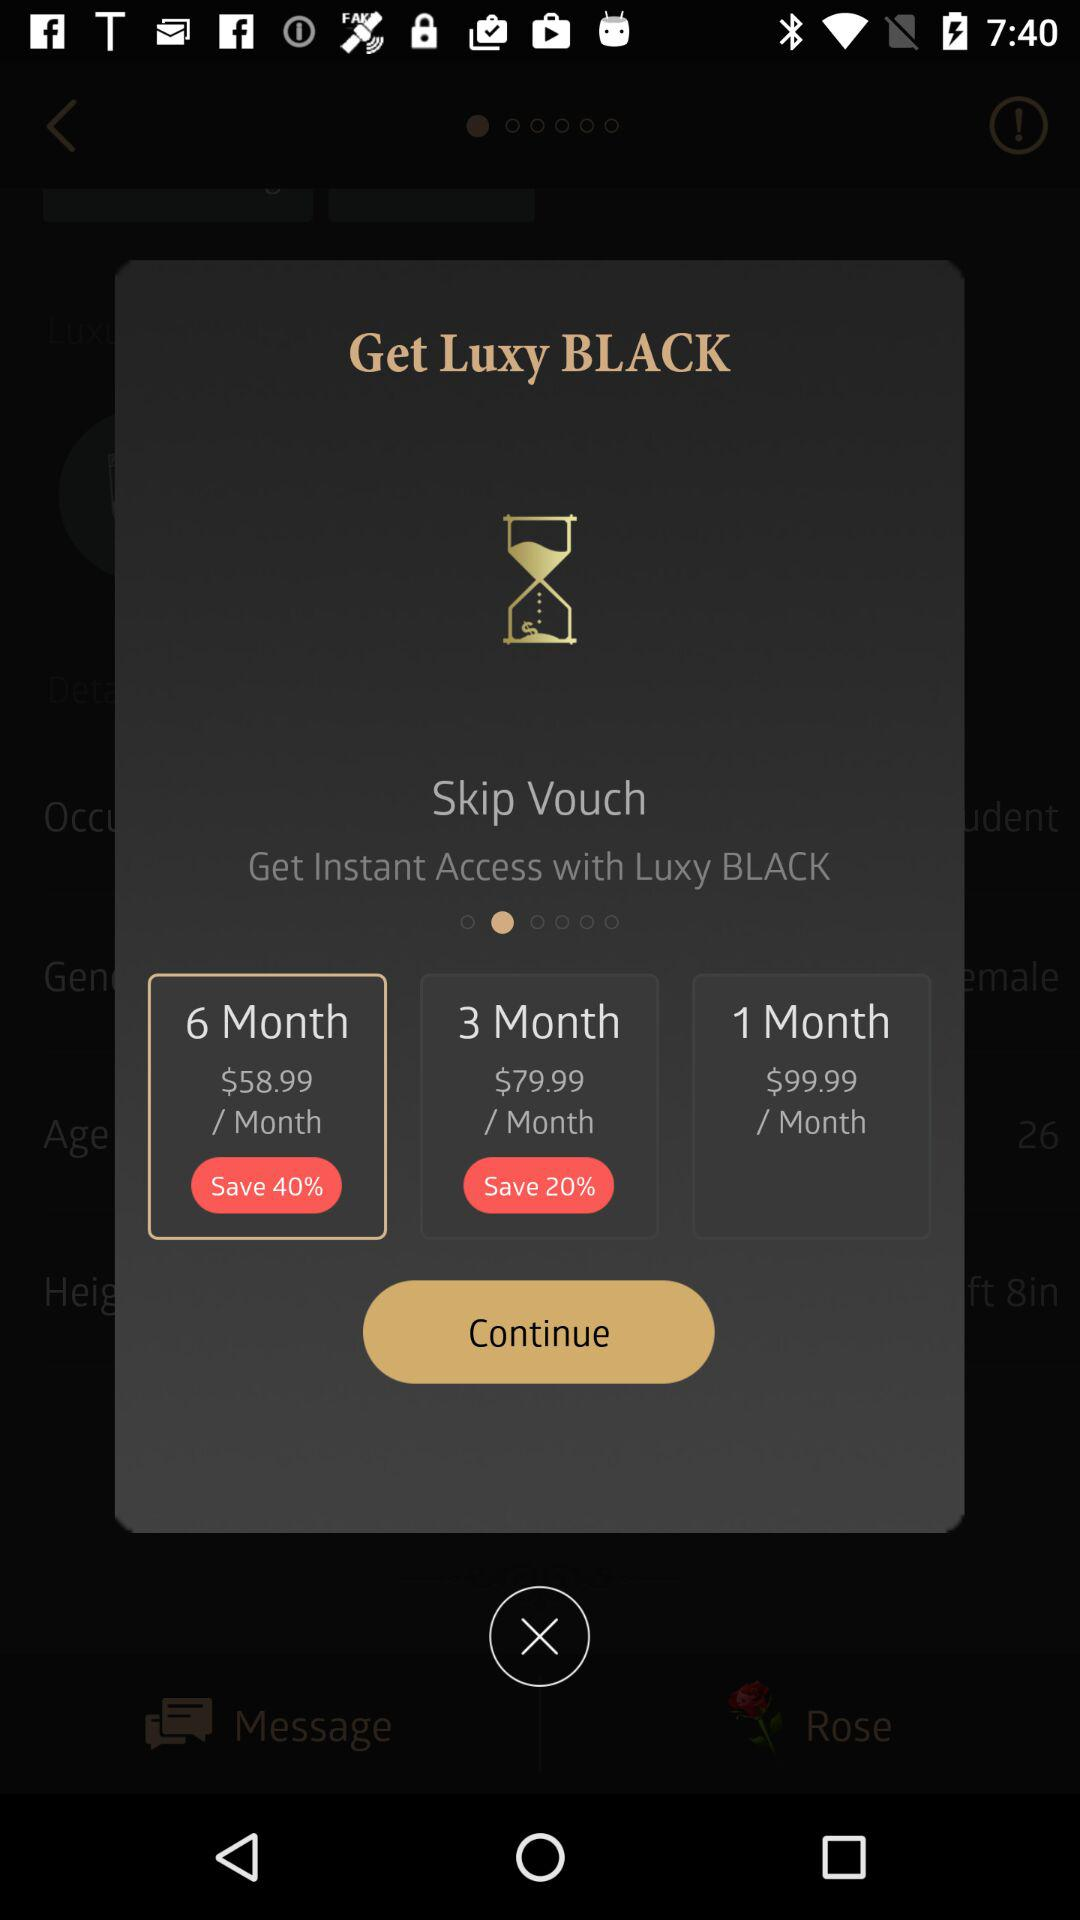How much does a 1-month subscription cost per month? A 1-month subscription costs $99.99 per month. 